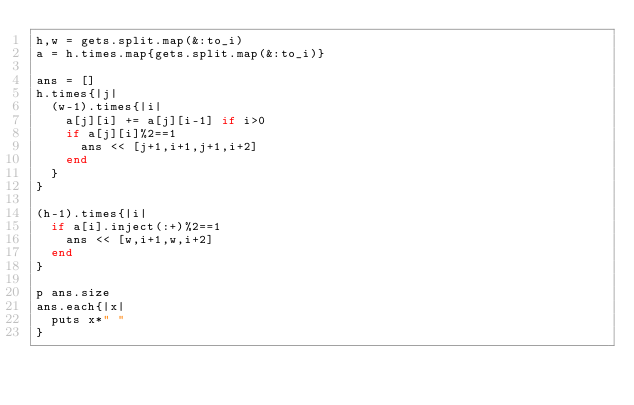Convert code to text. <code><loc_0><loc_0><loc_500><loc_500><_Ruby_>h,w = gets.split.map(&:to_i)
a = h.times.map{gets.split.map(&:to_i)}

ans = []
h.times{|j|
  (w-1).times{|i|
    a[j][i] += a[j][i-1] if i>0
    if a[j][i]%2==1
      ans << [j+1,i+1,j+1,i+2]
    end
  }
}

(h-1).times{|i|
  if a[i].inject(:+)%2==1
    ans << [w,i+1,w,i+2]
  end
}

p ans.size
ans.each{|x|
  puts x*" "
}</code> 